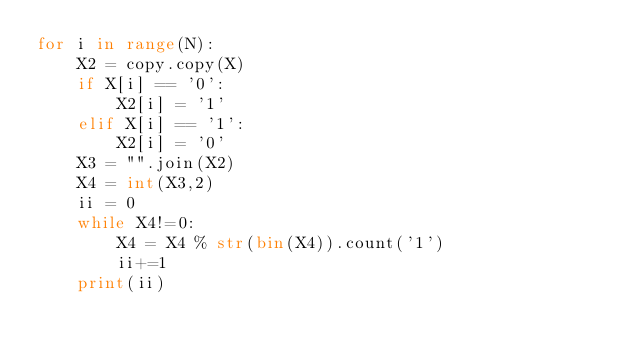Convert code to text. <code><loc_0><loc_0><loc_500><loc_500><_Python_>for i in range(N):
    X2 = copy.copy(X)
    if X[i] == '0':
        X2[i] = '1'
    elif X[i] == '1':
        X2[i] = '0'
    X3 = "".join(X2)
    X4 = int(X3,2)
    ii = 0
    while X4!=0:
        X4 = X4 % str(bin(X4)).count('1')
        ii+=1
    print(ii)</code> 